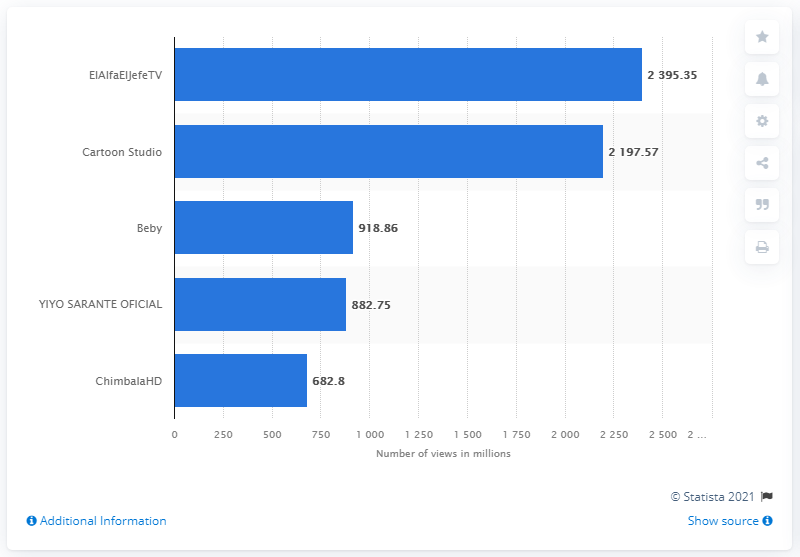Indicate a few pertinent items in this graphic. As of March 2021, the most viewed YouTube channel in the Dominican Republic was ElAlfaElJefeTV. According to the Dominican Republic, the second most viewed YouTube channel is Cartoon Studio. 